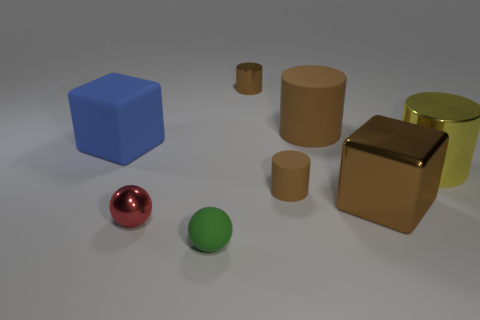Subtract all cyan blocks. How many brown cylinders are left? 3 Subtract all purple cylinders. Subtract all yellow spheres. How many cylinders are left? 4 Add 2 tiny red metal spheres. How many objects exist? 10 Subtract all spheres. How many objects are left? 6 Add 4 brown blocks. How many brown blocks are left? 5 Add 2 tiny brown cylinders. How many tiny brown cylinders exist? 4 Subtract 0 red blocks. How many objects are left? 8 Subtract all small metal things. Subtract all brown metallic things. How many objects are left? 4 